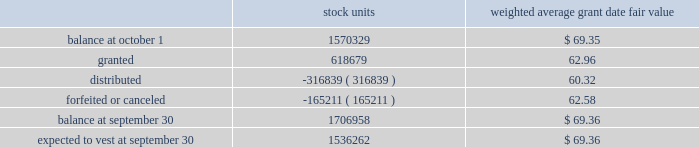The weighted average grant date fair value of performance-based restricted stock units granted during the years 2008 and 2007 was $ 84.33 and $ 71.72 , respectively .
The total fair value of performance-based restricted stock units vested during 2009 , 2008 and 2007 was $ 33712 , $ 49387 and $ 9181 , respectively .
At september 30 , 2009 , the weighted average remaining vesting term of performance-based restricted stock units is 1.28 years .
Time-vested restricted stock units time-vested restricted stock units generally cliff vest three years after the date of grant , except for certain key executives of the company , including the executive officers , for which such units generally vest one year following the employee 2019s retirement .
The related share-based compensation expense is recorded over the requisite service period , which is the vesting period or in the case of certain key executives is based on retirement eligibility .
The fair value of all time-vested restricted stock units is based on the market value of the company 2019s stock on the date of grant .
A summary of time-vested restricted stock units outstanding as of september 30 , 2009 , and changes during the year then ended is as follows : weighted average grant date fair value .
The weighted average grant date fair value of time-vested restricted stock units granted during the years 2008 and 2007 was $ 84.42 and $ 72.20 , respectively .
The total fair value of time-vested restricted stock units vested during 2009 , 2008 and 2007 was $ 29535 , $ 26674 and $ 3392 , respectively .
At september 30 , 2009 , the weighted average remaining vesting term of the time-vested restricted stock units is 1.71 years .
The amount of unrecognized compensation expense for all non-vested share-based awards as of september 30 , 2009 , is approximately $ 97034 , which is expected to be recognized over a weighted-average remaining life of approximately 2.02 years .
At september 30 , 2009 , 4295402 shares were authorized for future grants under the 2004 plan .
The company has a policy of satisfying share-based payments through either open market purchases or shares held in treasury .
At september 30 , 2009 , the company has sufficient shares held in treasury to satisfy these payments in 2010 .
Other stock plans the company has a stock award plan , which allows for grants of common shares to certain key employees .
Distribution of 25% ( 25 % ) or more of each award is deferred until after retirement or involuntary termination , upon which the deferred portion of the award is distributable in five equal annual installments .
The balance of the award is distributable over five years from the grant date , subject to certain conditions .
In february 2004 , this plan was terminated with respect to future grants upon the adoption of the 2004 plan .
At september 30 , 2009 and 2008 , awards for 114197 and 161145 shares , respectively , were outstanding .
Becton , dickinson and company notes to consolidated financial statements 2014 ( continued ) .
What is the total fair value of performance-based restricted stock units vested during 2009 , 2008 and 2007? 
Computations: ((33712 + 49387) + 9181)
Answer: 92280.0. 